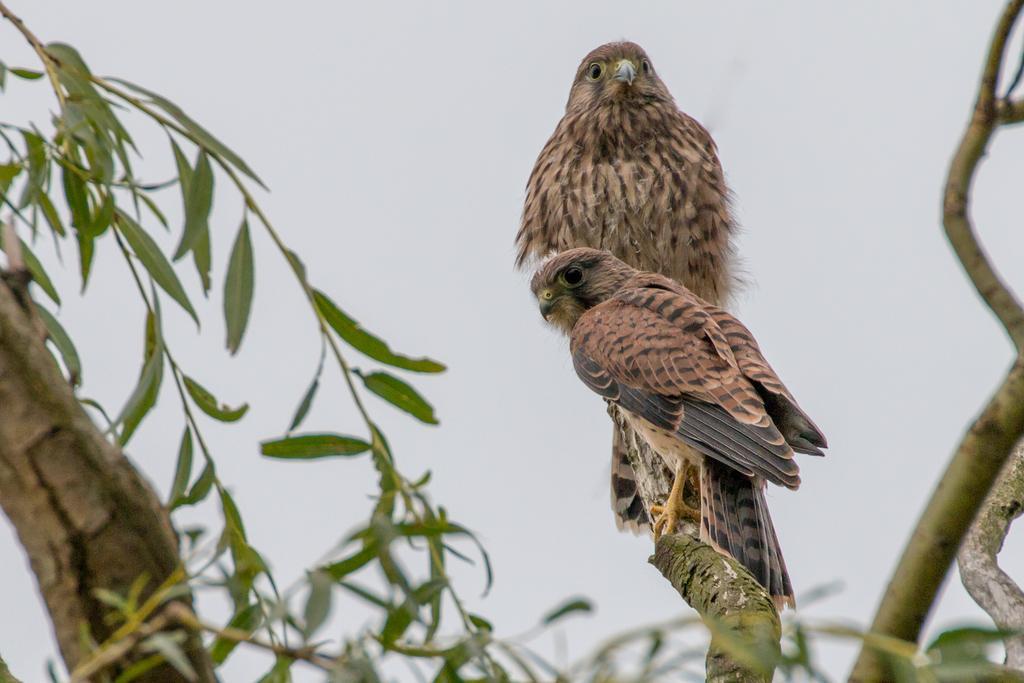Describe this image in one or two sentences. In this image there are two hawks standing on the tree stem. On the left side there are green leaves. On the right side there are tree stems. 